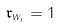Convert formula to latex. <formula><loc_0><loc_0><loc_500><loc_500>\mathfrak { r } _ { w _ { i } } = 1</formula> 